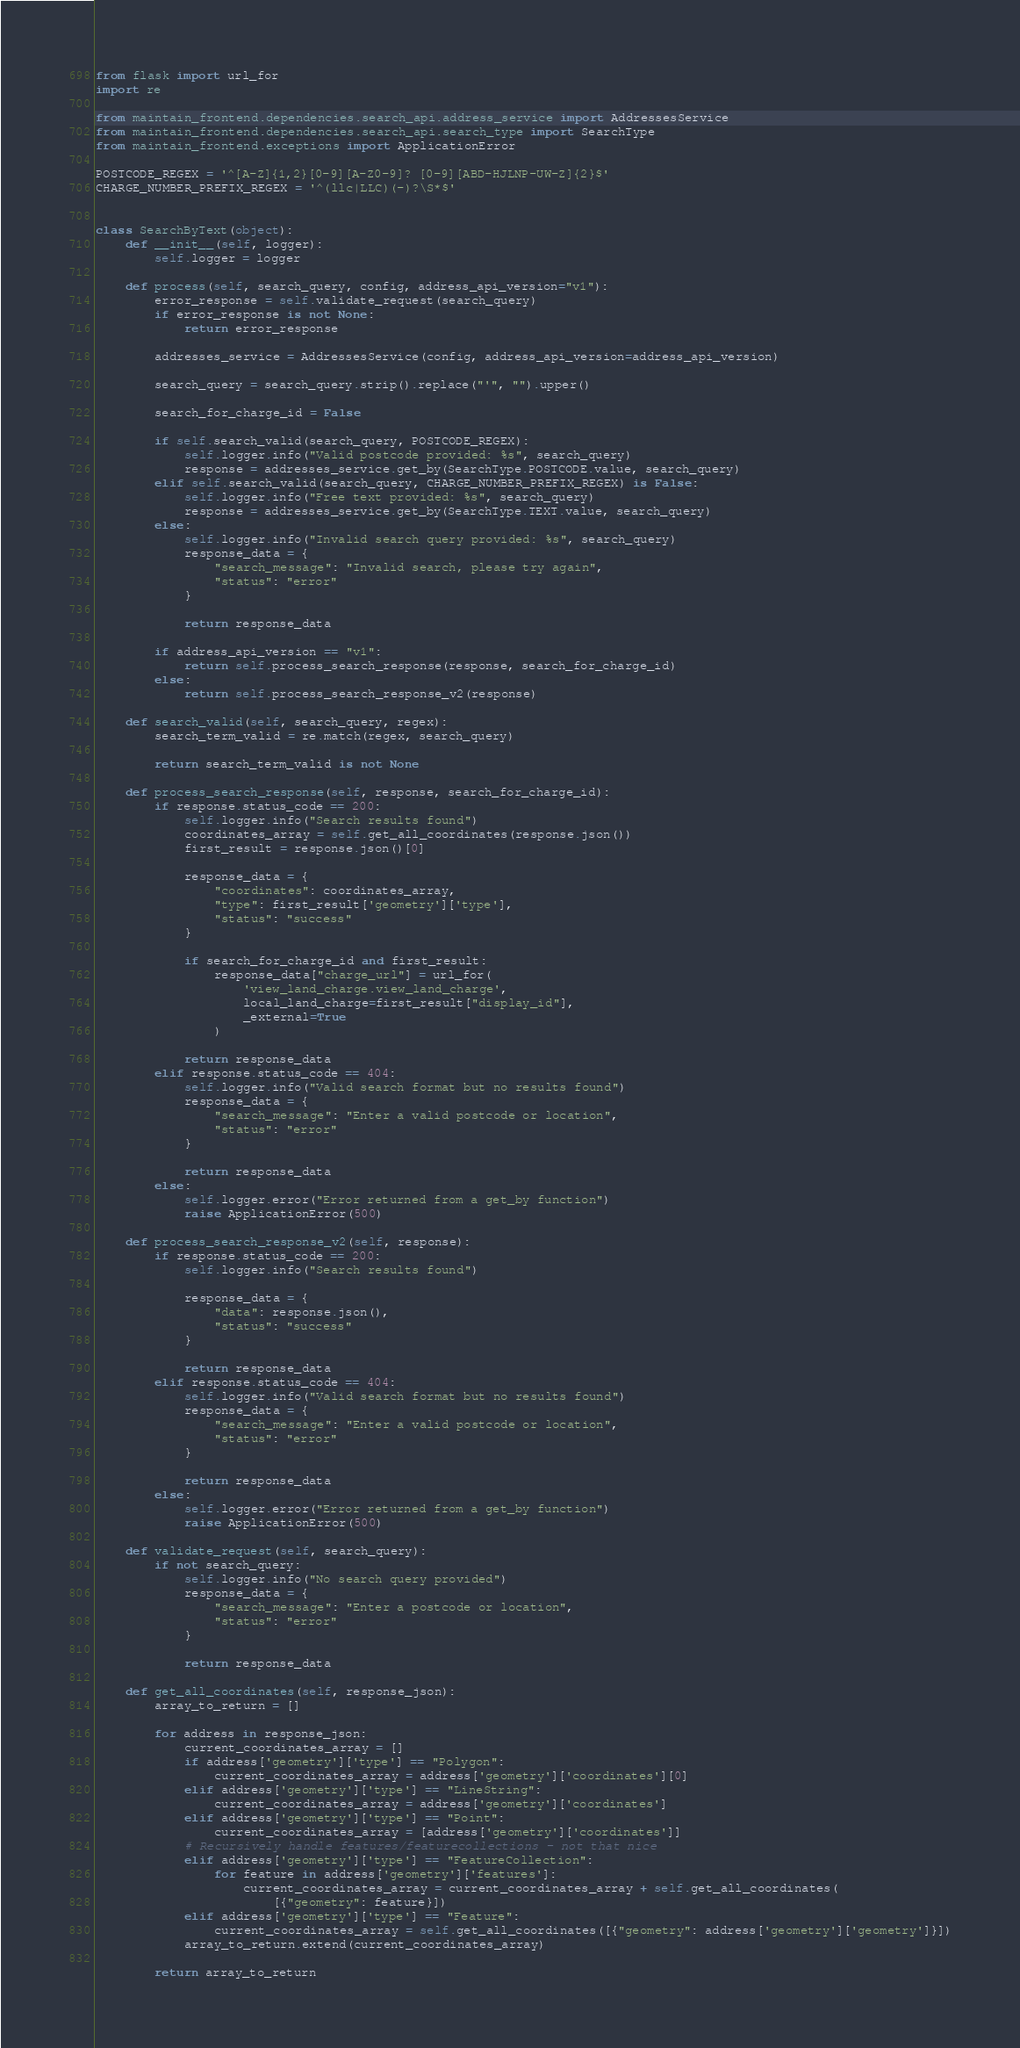Convert code to text. <code><loc_0><loc_0><loc_500><loc_500><_Python_>from flask import url_for
import re

from maintain_frontend.dependencies.search_api.address_service import AddressesService
from maintain_frontend.dependencies.search_api.search_type import SearchType
from maintain_frontend.exceptions import ApplicationError

POSTCODE_REGEX = '^[A-Z]{1,2}[0-9][A-Z0-9]? [0-9][ABD-HJLNP-UW-Z]{2}$'
CHARGE_NUMBER_PREFIX_REGEX = '^(llc|LLC)(-)?\S*$'


class SearchByText(object):
    def __init__(self, logger):
        self.logger = logger

    def process(self, search_query, config, address_api_version="v1"):
        error_response = self.validate_request(search_query)
        if error_response is not None:
            return error_response

        addresses_service = AddressesService(config, address_api_version=address_api_version)

        search_query = search_query.strip().replace("'", "").upper()

        search_for_charge_id = False

        if self.search_valid(search_query, POSTCODE_REGEX):
            self.logger.info("Valid postcode provided: %s", search_query)
            response = addresses_service.get_by(SearchType.POSTCODE.value, search_query)
        elif self.search_valid(search_query, CHARGE_NUMBER_PREFIX_REGEX) is False:
            self.logger.info("Free text provided: %s", search_query)
            response = addresses_service.get_by(SearchType.TEXT.value, search_query)
        else:
            self.logger.info("Invalid search query provided: %s", search_query)
            response_data = {
                "search_message": "Invalid search, please try again",
                "status": "error"
            }

            return response_data

        if address_api_version == "v1":
            return self.process_search_response(response, search_for_charge_id)
        else:
            return self.process_search_response_v2(response)

    def search_valid(self, search_query, regex):
        search_term_valid = re.match(regex, search_query)

        return search_term_valid is not None

    def process_search_response(self, response, search_for_charge_id):
        if response.status_code == 200:
            self.logger.info("Search results found")
            coordinates_array = self.get_all_coordinates(response.json())
            first_result = response.json()[0]

            response_data = {
                "coordinates": coordinates_array,
                "type": first_result['geometry']['type'],
                "status": "success"
            }

            if search_for_charge_id and first_result:
                response_data["charge_url"] = url_for(
                    'view_land_charge.view_land_charge',
                    local_land_charge=first_result["display_id"],
                    _external=True
                )

            return response_data
        elif response.status_code == 404:
            self.logger.info("Valid search format but no results found")
            response_data = {
                "search_message": "Enter a valid postcode or location",
                "status": "error"
            }

            return response_data
        else:
            self.logger.error("Error returned from a get_by function")
            raise ApplicationError(500)

    def process_search_response_v2(self, response):
        if response.status_code == 200:
            self.logger.info("Search results found")

            response_data = {
                "data": response.json(),
                "status": "success"
            }

            return response_data
        elif response.status_code == 404:
            self.logger.info("Valid search format but no results found")
            response_data = {
                "search_message": "Enter a valid postcode or location",
                "status": "error"
            }

            return response_data
        else:
            self.logger.error("Error returned from a get_by function")
            raise ApplicationError(500)

    def validate_request(self, search_query):
        if not search_query:
            self.logger.info("No search query provided")
            response_data = {
                "search_message": "Enter a postcode or location",
                "status": "error"
            }

            return response_data

    def get_all_coordinates(self, response_json):
        array_to_return = []

        for address in response_json:
            current_coordinates_array = []
            if address['geometry']['type'] == "Polygon":
                current_coordinates_array = address['geometry']['coordinates'][0]
            elif address['geometry']['type'] == "LineString":
                current_coordinates_array = address['geometry']['coordinates']
            elif address['geometry']['type'] == "Point":
                current_coordinates_array = [address['geometry']['coordinates']]
            # Recursively handle features/featurecollections - not that nice
            elif address['geometry']['type'] == "FeatureCollection":
                for feature in address['geometry']['features']:
                    current_coordinates_array = current_coordinates_array + self.get_all_coordinates(
                        [{"geometry": feature}])
            elif address['geometry']['type'] == "Feature":
                current_coordinates_array = self.get_all_coordinates([{"geometry": address['geometry']['geometry']}])
            array_to_return.extend(current_coordinates_array)

        return array_to_return
</code> 